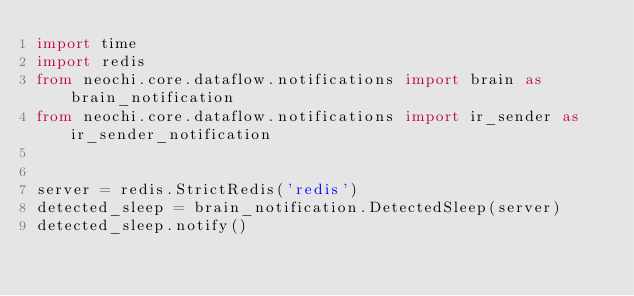Convert code to text. <code><loc_0><loc_0><loc_500><loc_500><_Python_>import time
import redis
from neochi.core.dataflow.notifications import brain as brain_notification
from neochi.core.dataflow.notifications import ir_sender as ir_sender_notification


server = redis.StrictRedis('redis')
detected_sleep = brain_notification.DetectedSleep(server)
detected_sleep.notify()</code> 